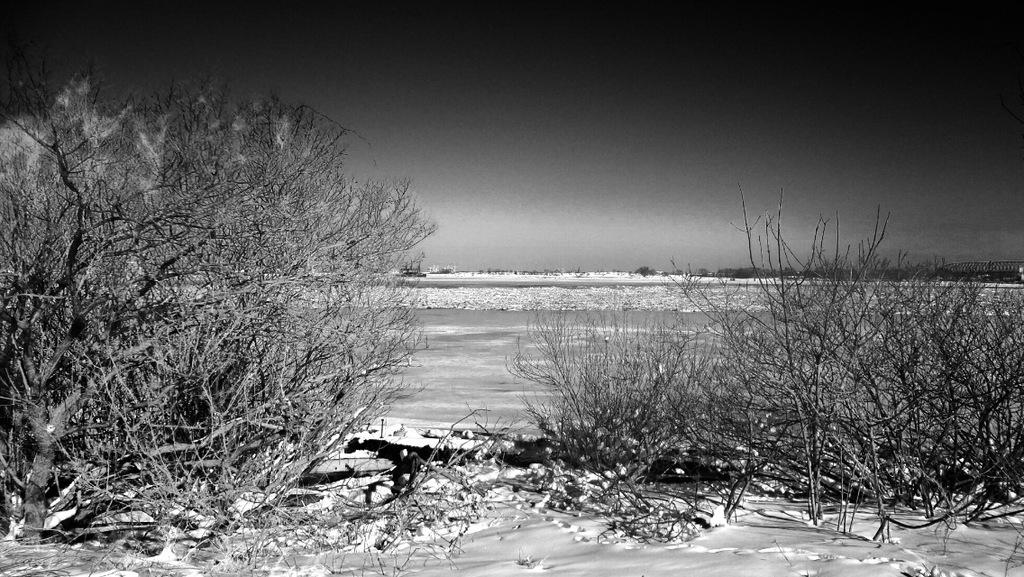Where was the image taken? The image was clicked outside the city. What can be seen in the foreground of the image? There is ground visible in the foreground, along with plants and a tree. What is visible in the background of the image? The sky is visible in the background, and there appears to be a water body. How many men are kicking a ball in the image? There are no men or balls present in the image. 